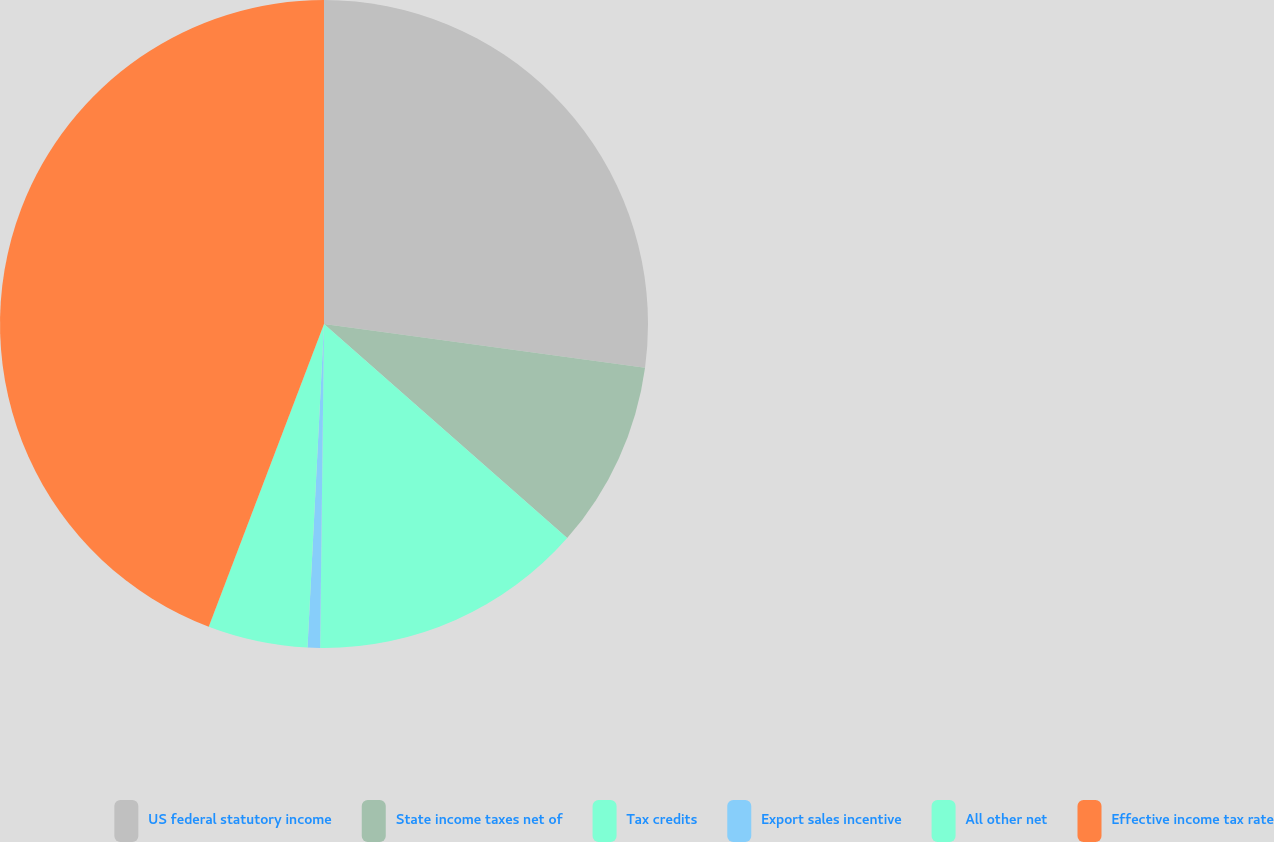<chart> <loc_0><loc_0><loc_500><loc_500><pie_chart><fcel>US federal statutory income<fcel>State income taxes net of<fcel>Tax credits<fcel>Export sales incentive<fcel>All other net<fcel>Effective income tax rate<nl><fcel>27.15%<fcel>9.34%<fcel>13.7%<fcel>0.62%<fcel>4.98%<fcel>44.21%<nl></chart> 